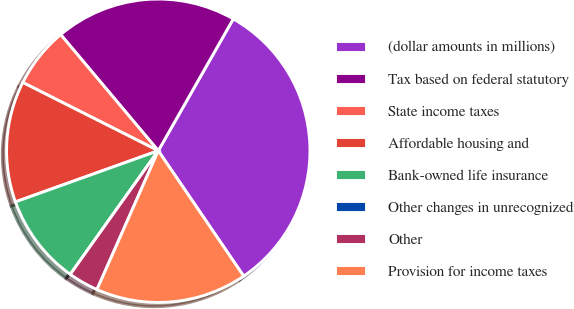<chart> <loc_0><loc_0><loc_500><loc_500><pie_chart><fcel>(dollar amounts in millions)<fcel>Tax based on federal statutory<fcel>State income taxes<fcel>Affordable housing and<fcel>Bank-owned life insurance<fcel>Other changes in unrecognized<fcel>Other<fcel>Provision for income taxes<nl><fcel>32.25%<fcel>19.35%<fcel>6.45%<fcel>12.9%<fcel>9.68%<fcel>0.0%<fcel>3.23%<fcel>16.13%<nl></chart> 